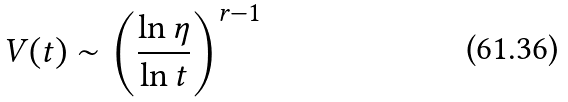Convert formula to latex. <formula><loc_0><loc_0><loc_500><loc_500>V ( t ) \sim \left ( \frac { \ln \eta } { \ln t } \right ) ^ { r - 1 }</formula> 